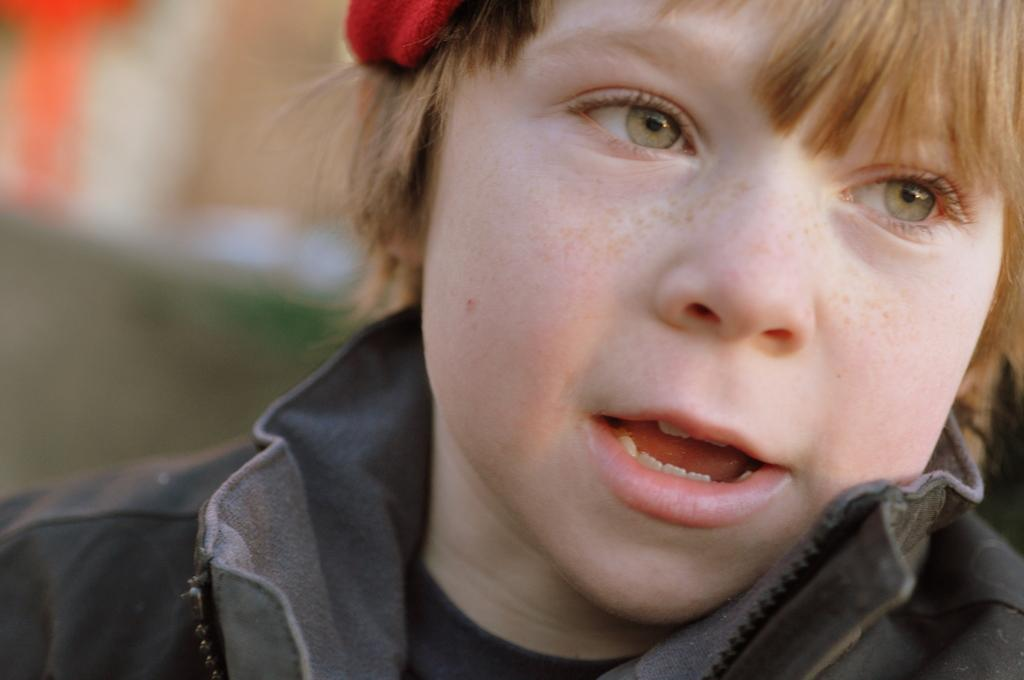Who is the main subject in the image? There is a boy in the image. What is the boy wearing? The boy is wearing a black dress. What color is the prominent object in the image? There is a red object in the image. Can you describe the background of the image? The background of the image is blurry. What type of nerve is visible in the image? There is no nerve present in the image. What kind of jewel is the boy holding in the image? There is no jewel present in the image. 